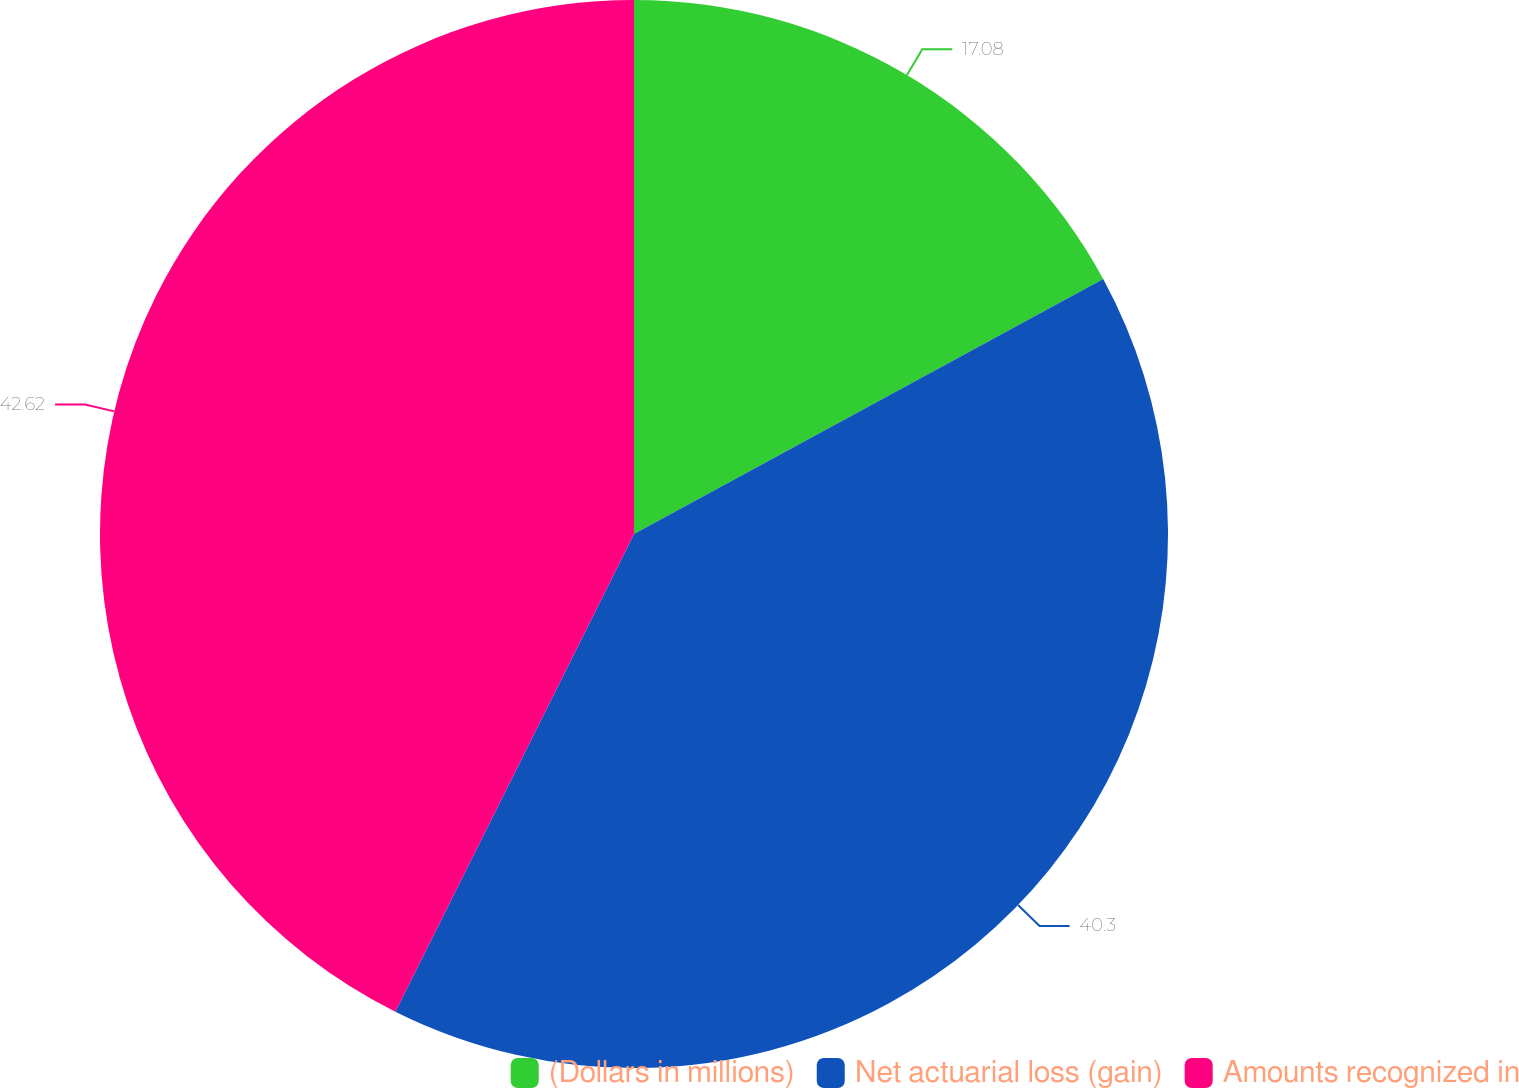<chart> <loc_0><loc_0><loc_500><loc_500><pie_chart><fcel>(Dollars in millions)<fcel>Net actuarial loss (gain)<fcel>Amounts recognized in<nl><fcel>17.08%<fcel>40.3%<fcel>42.63%<nl></chart> 